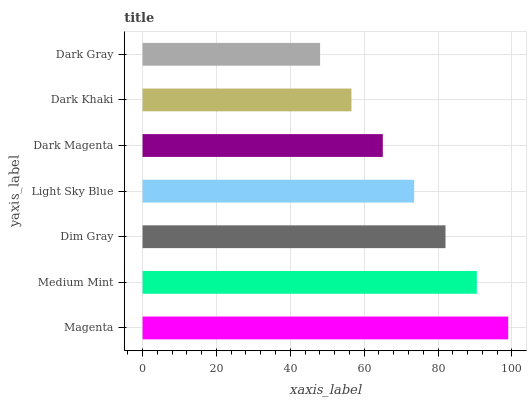Is Dark Gray the minimum?
Answer yes or no. Yes. Is Magenta the maximum?
Answer yes or no. Yes. Is Medium Mint the minimum?
Answer yes or no. No. Is Medium Mint the maximum?
Answer yes or no. No. Is Magenta greater than Medium Mint?
Answer yes or no. Yes. Is Medium Mint less than Magenta?
Answer yes or no. Yes. Is Medium Mint greater than Magenta?
Answer yes or no. No. Is Magenta less than Medium Mint?
Answer yes or no. No. Is Light Sky Blue the high median?
Answer yes or no. Yes. Is Light Sky Blue the low median?
Answer yes or no. Yes. Is Magenta the high median?
Answer yes or no. No. Is Dark Gray the low median?
Answer yes or no. No. 